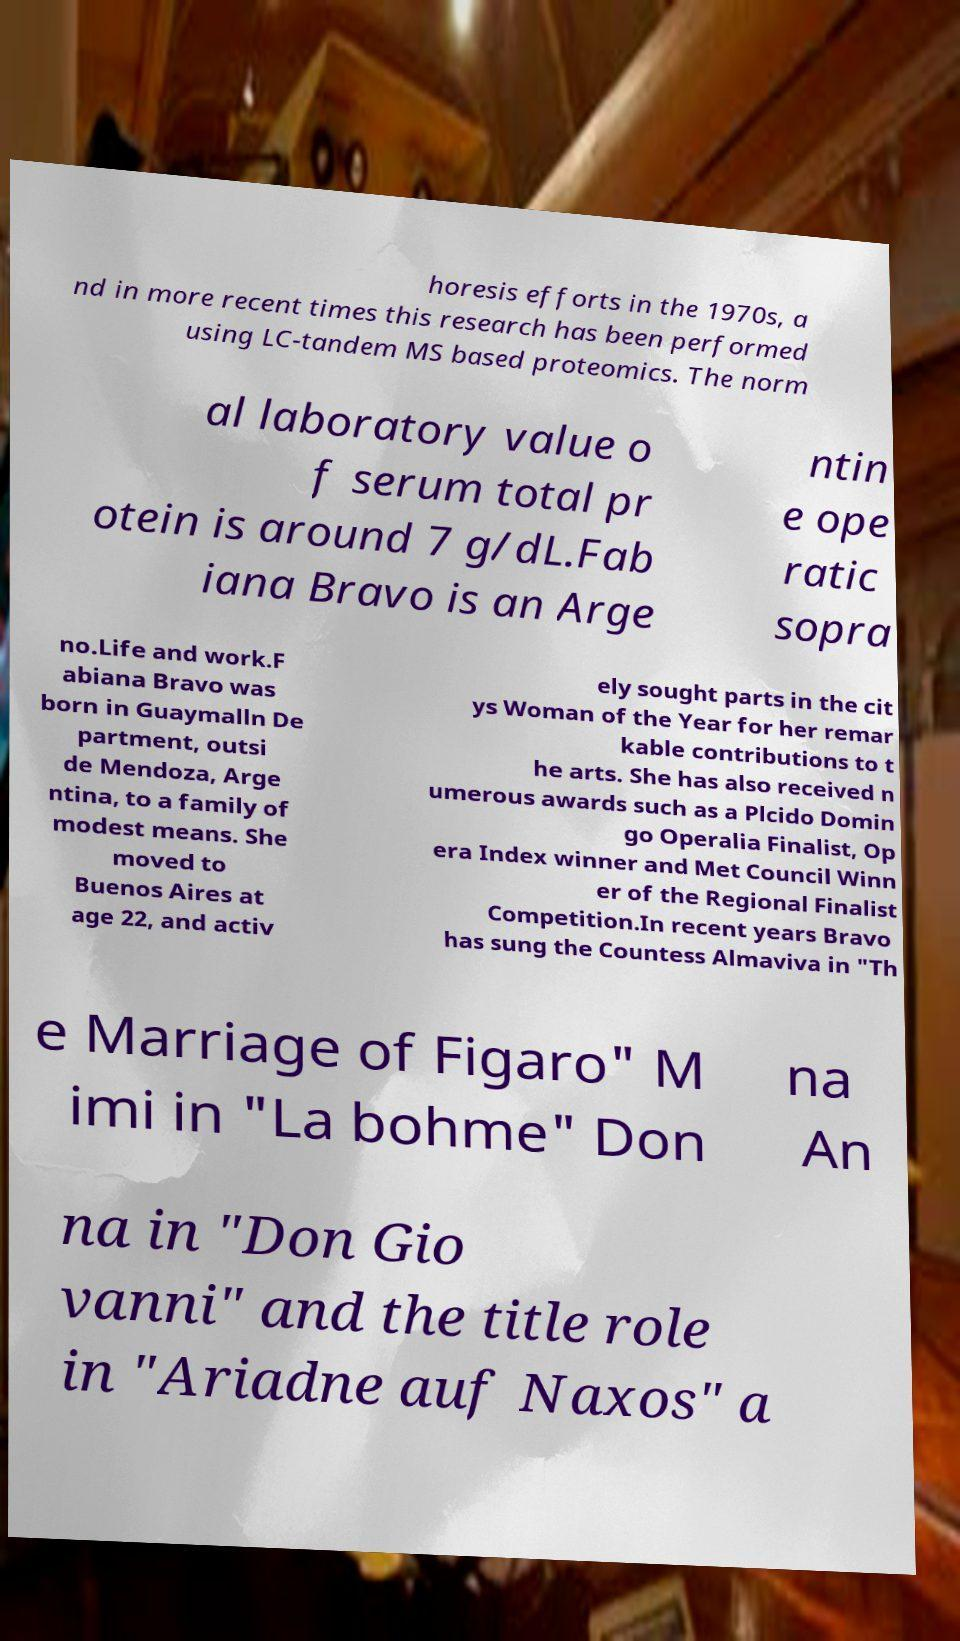Could you extract and type out the text from this image? horesis efforts in the 1970s, a nd in more recent times this research has been performed using LC-tandem MS based proteomics. The norm al laboratory value o f serum total pr otein is around 7 g/dL.Fab iana Bravo is an Arge ntin e ope ratic sopra no.Life and work.F abiana Bravo was born in Guaymalln De partment, outsi de Mendoza, Arge ntina, to a family of modest means. She moved to Buenos Aires at age 22, and activ ely sought parts in the cit ys Woman of the Year for her remar kable contributions to t he arts. She has also received n umerous awards such as a Plcido Domin go Operalia Finalist, Op era Index winner and Met Council Winn er of the Regional Finalist Competition.In recent years Bravo has sung the Countess Almaviva in "Th e Marriage of Figaro" M imi in "La bohme" Don na An na in "Don Gio vanni" and the title role in "Ariadne auf Naxos" a 